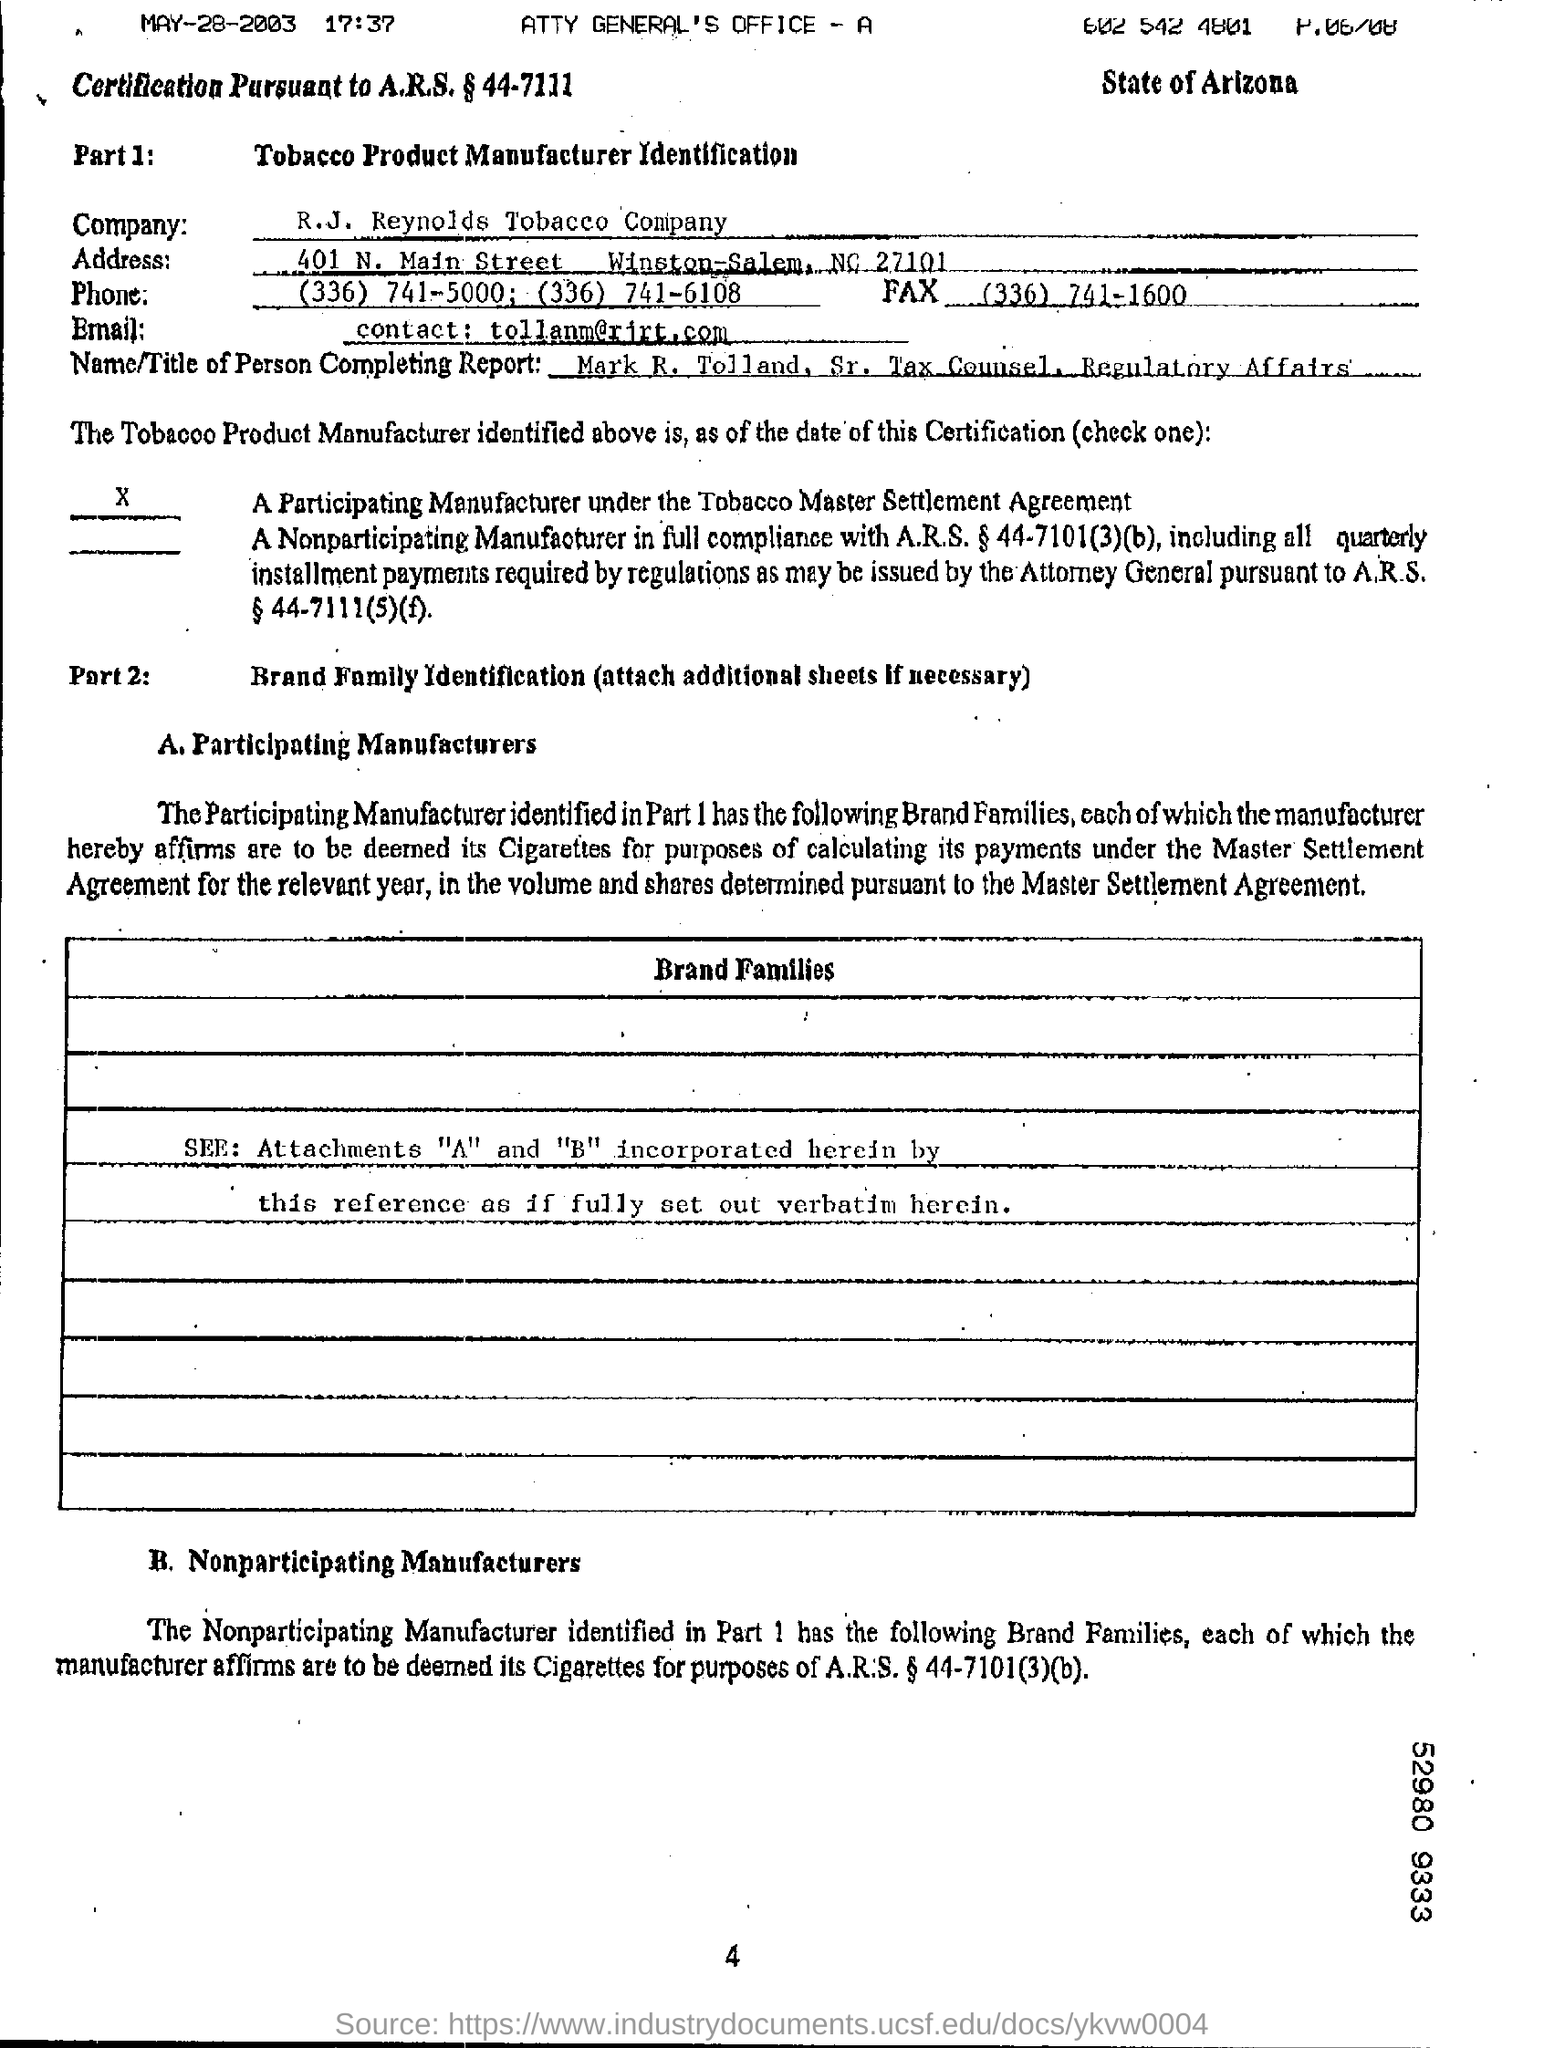Specify some key components in this picture. The fax number is (336) 741-1600. The date mentioned at the top left of the document is May 28, 2003. The R.J. Reynolds Tobacco Company is the company in question. 